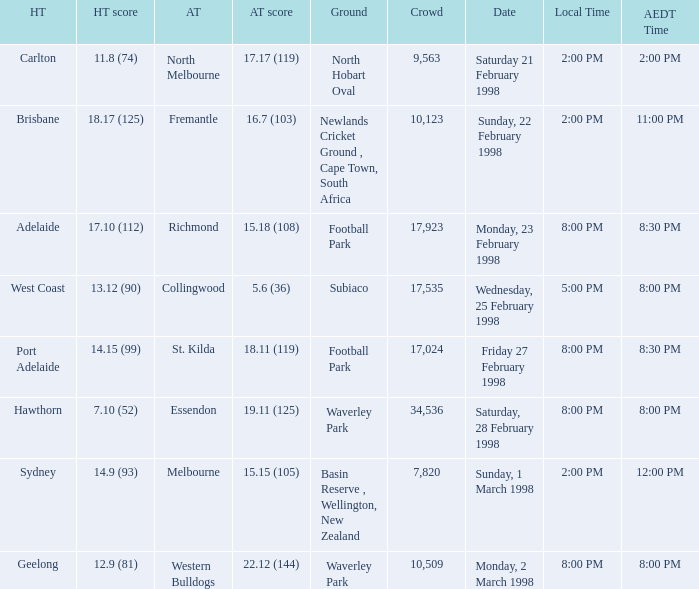Name the AEDT Time which has an Away team of collingwood? 8:00 PM. 